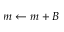<formula> <loc_0><loc_0><loc_500><loc_500>m \gets m + B</formula> 